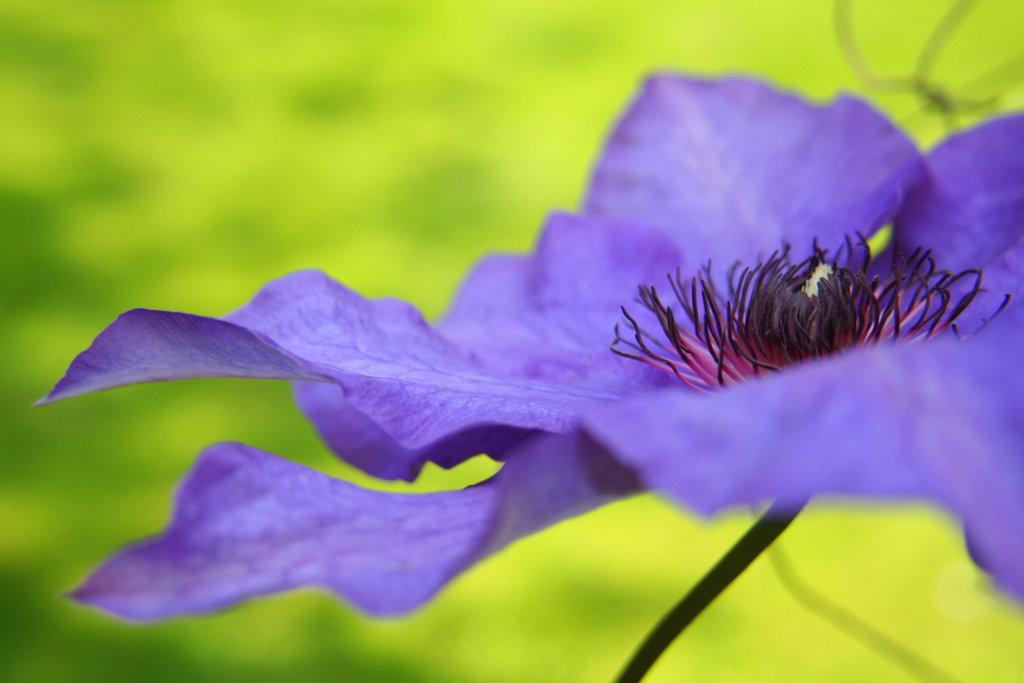What is the main subject of the image? There is a flower in the image. Can you describe the background of the image? The background is green and blurred. How many feet can be seen in the image? There are no feet visible in the image; it features a flower and a green, blurred background. What type of kitten can be seen playing in the park in the image? There is no kitten or park present in the image; it only features a flower and a green, blurred background. 